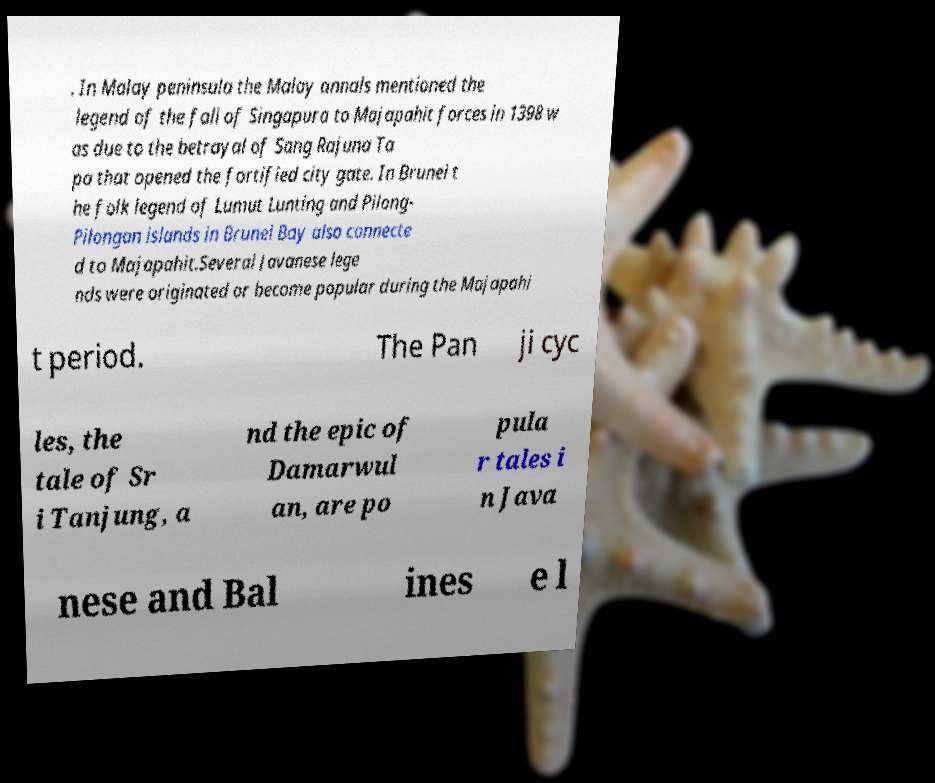There's text embedded in this image that I need extracted. Can you transcribe it verbatim? . In Malay peninsula the Malay annals mentioned the legend of the fall of Singapura to Majapahit forces in 1398 w as due to the betrayal of Sang Rajuna Ta pa that opened the fortified city gate. In Brunei t he folk legend of Lumut Lunting and Pilong- Pilongan islands in Brunei Bay also connecte d to Majapahit.Several Javanese lege nds were originated or become popular during the Majapahi t period. The Pan ji cyc les, the tale of Sr i Tanjung, a nd the epic of Damarwul an, are po pula r tales i n Java nese and Bal ines e l 